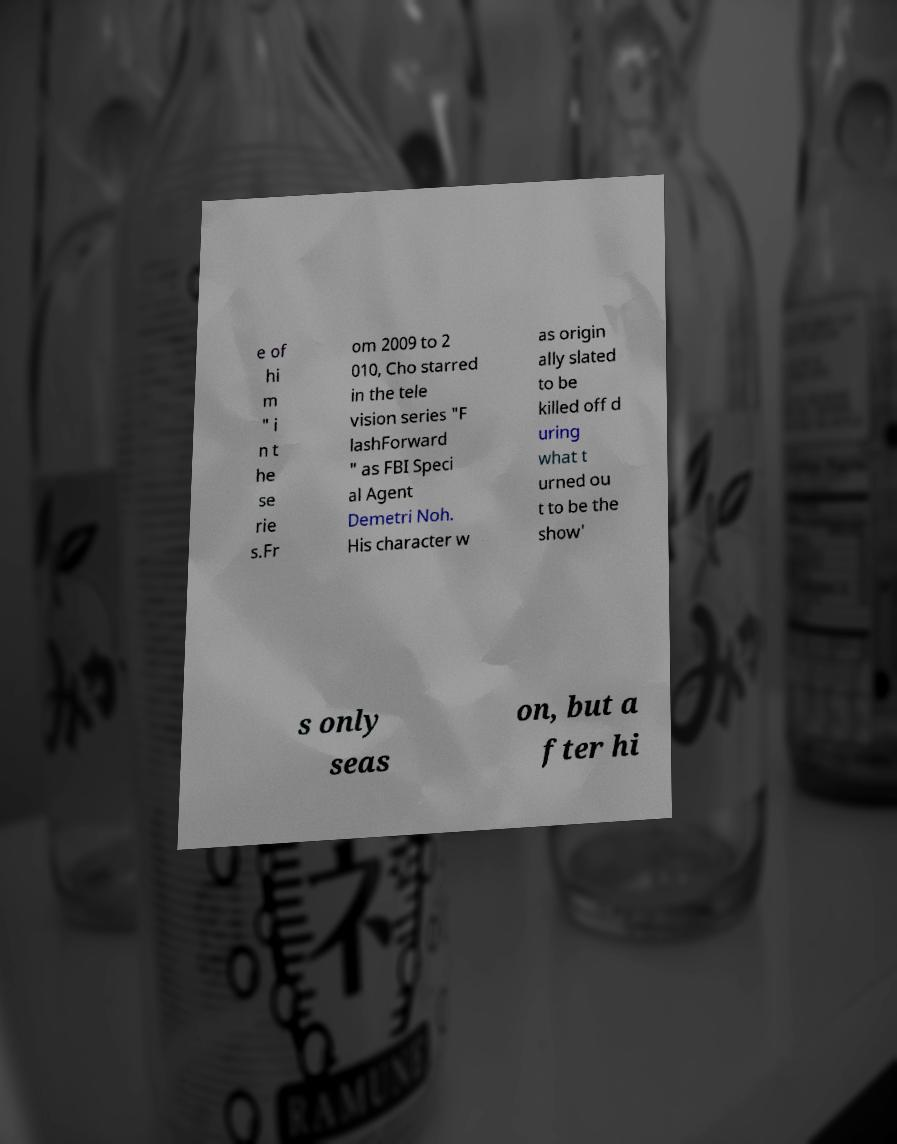Please read and relay the text visible in this image. What does it say? e of hi m " i n t he se rie s.Fr om 2009 to 2 010, Cho starred in the tele vision series "F lashForward " as FBI Speci al Agent Demetri Noh. His character w as origin ally slated to be killed off d uring what t urned ou t to be the show' s only seas on, but a fter hi 